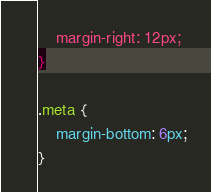<code> <loc_0><loc_0><loc_500><loc_500><_CSS_>    margin-right: 12px;
}

.meta {
    margin-bottom: 6px;
}</code> 